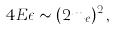<formula> <loc_0><loc_0><loc_500><loc_500>4 E \epsilon \sim ( 2 m _ { e } ) ^ { 2 } \, ,</formula> 